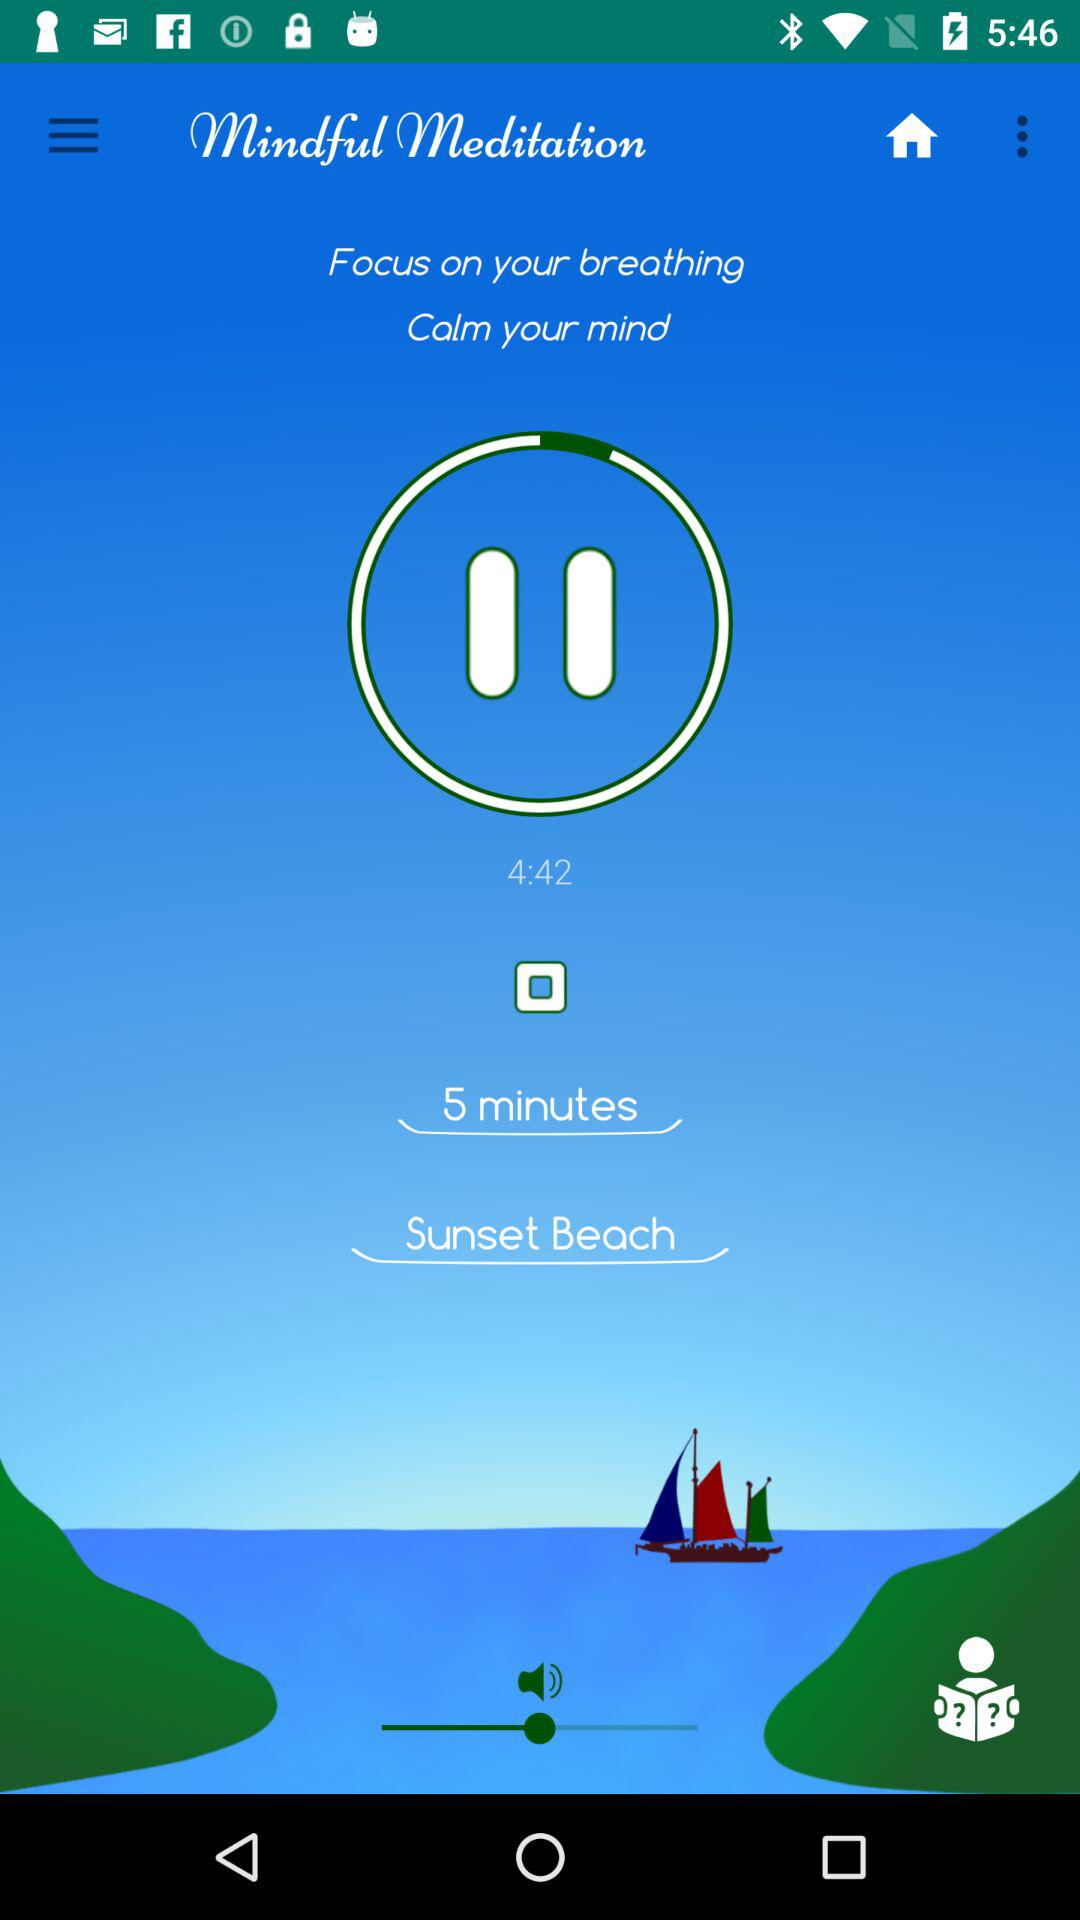What is the session time set for meditation? The session time set for meditation is 5 minutes. 